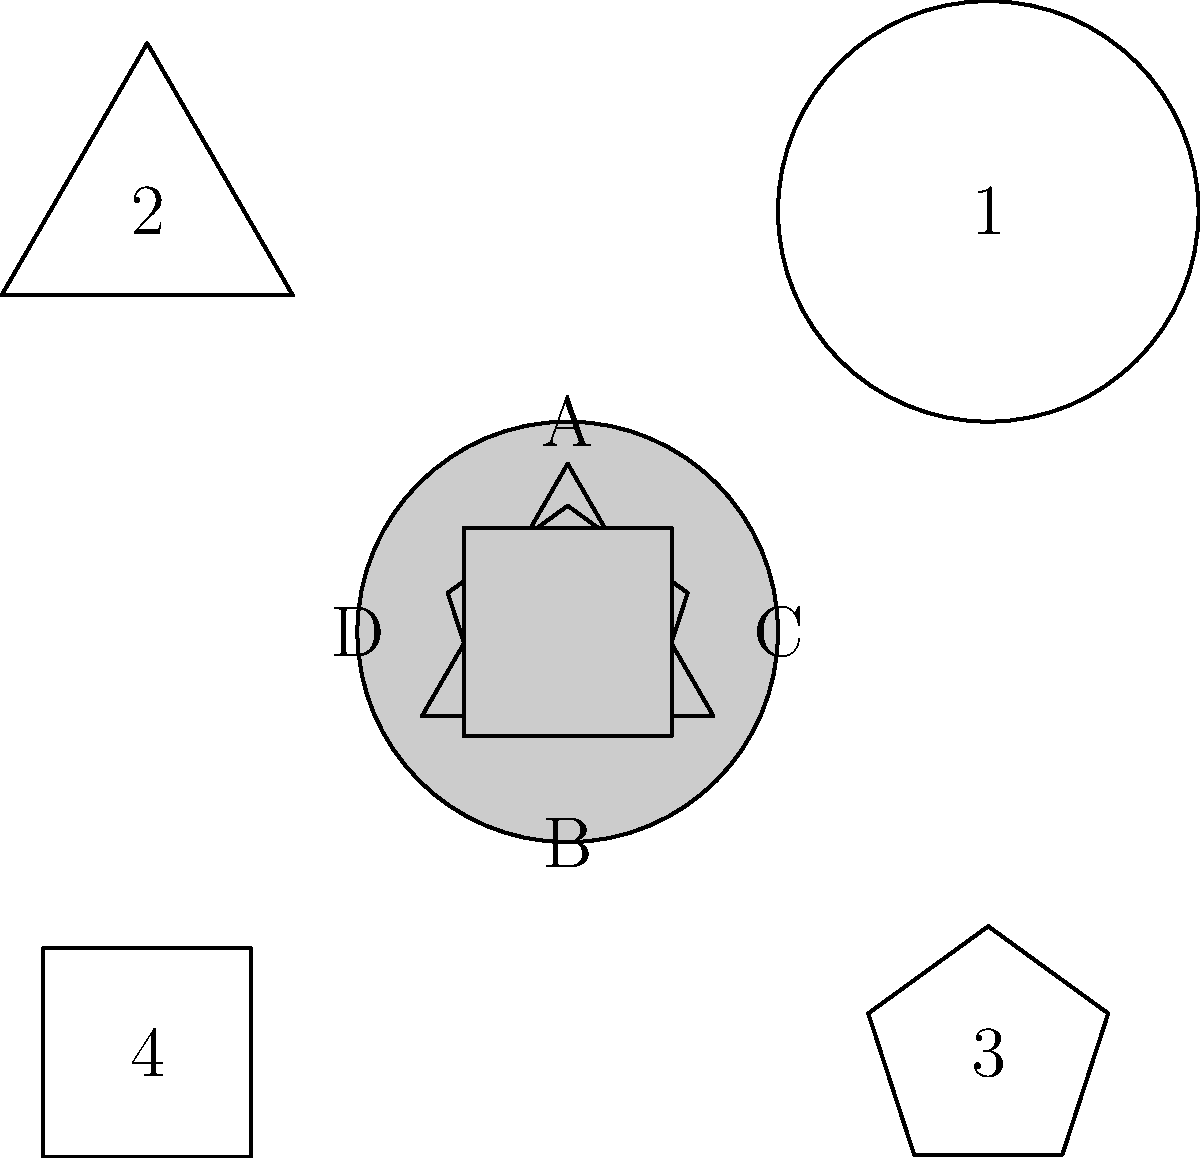In the image above, four shapes (A, B, C, and D) are shown alongside their corresponding negative spaces (1, 2, 3, and 4). Match each shape to its correct negative space. Which negative space corresponds to shape C? To solve this problem, we need to analyze each shape and its corresponding negative space carefully. Let's go through the process step-by-step:

1. Identify shape C: Shape C is a regular pentagon.

2. Examine the negative spaces:
   - Space 1 (top right) is a circle
   - Space 2 (top left) is a triangle
   - Space 3 (bottom right) is a pentagon
   - Space 4 (bottom left) is a square

3. Match the shape to its negative space:
   - The pentagon (shape C) corresponds to the pentagon-shaped negative space.

4. Locate the matching negative space:
   - The pentagon-shaped negative space is found in position 3 (bottom right).

Therefore, the negative space that corresponds to shape C is number 3.
Answer: 3 